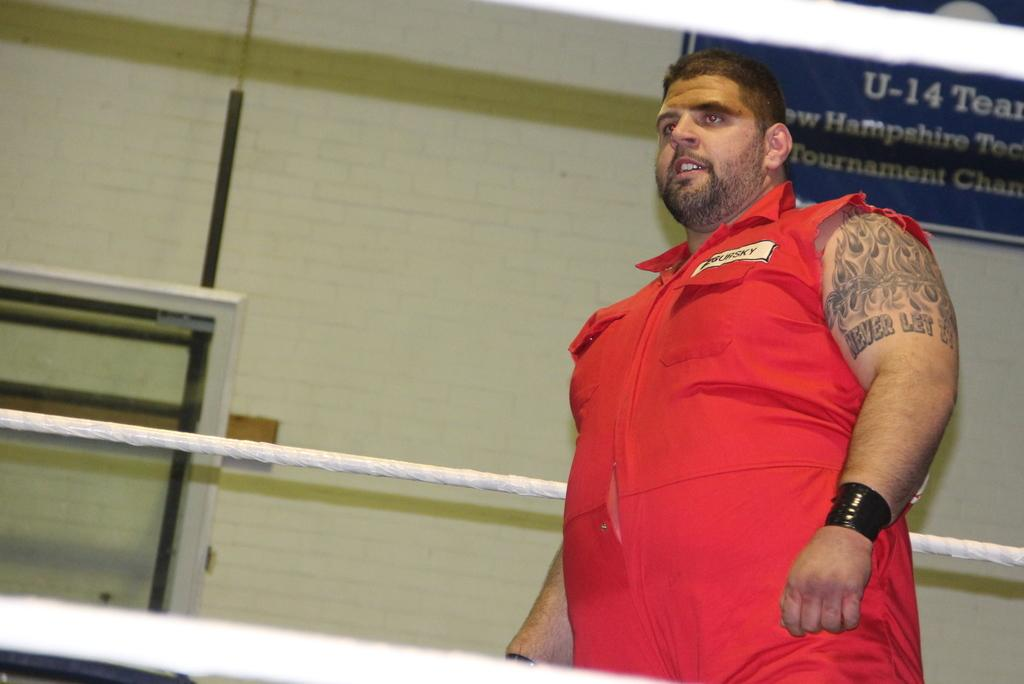<image>
Share a concise interpretation of the image provided. A blue sign reading U-14 Team hangs on the wall behind a burly man dressed in orange. 